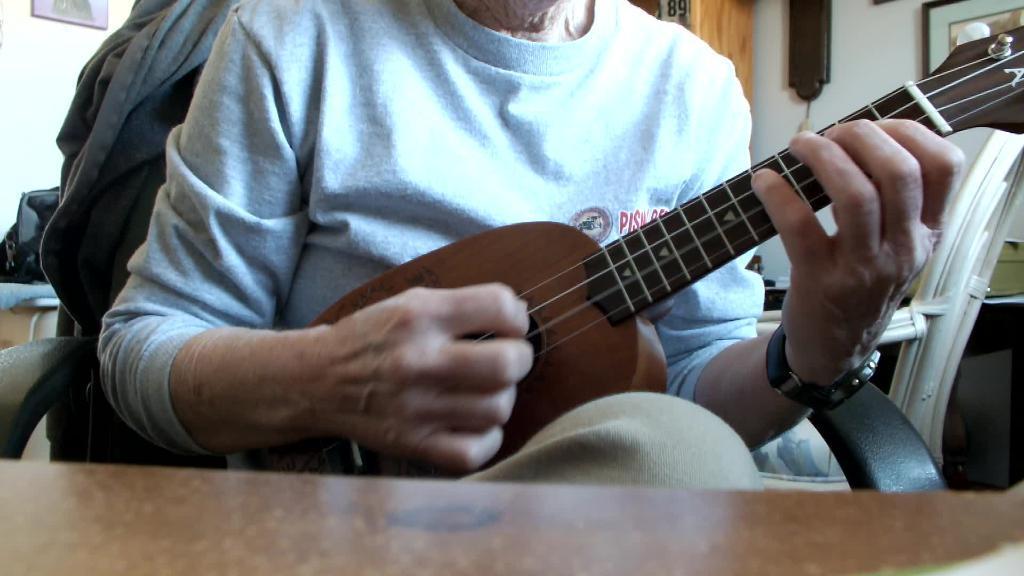Could you give a brief overview of what you see in this image? In this image I can see a person is holding a musical instrument. I can also see a chair and a table. 